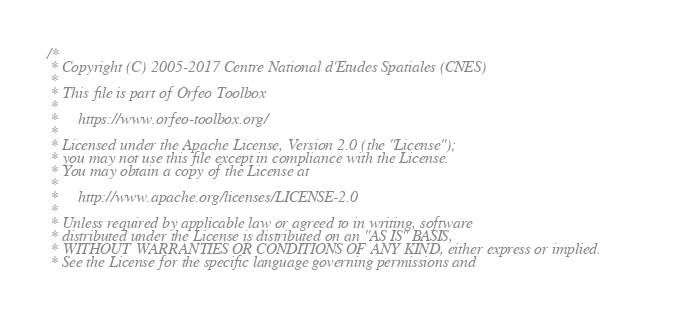<code> <loc_0><loc_0><loc_500><loc_500><_C++_>/*
 * Copyright (C) 2005-2017 Centre National d'Etudes Spatiales (CNES)
 *
 * This file is part of Orfeo Toolbox
 *
 *     https://www.orfeo-toolbox.org/
 *
 * Licensed under the Apache License, Version 2.0 (the "License");
 * you may not use this file except in compliance with the License.
 * You may obtain a copy of the License at
 *
 *     http://www.apache.org/licenses/LICENSE-2.0
 *
 * Unless required by applicable law or agreed to in writing, software
 * distributed under the License is distributed on an "AS IS" BASIS,
 * WITHOUT WARRANTIES OR CONDITIONS OF ANY KIND, either express or implied.
 * See the License for the specific language governing permissions and</code> 